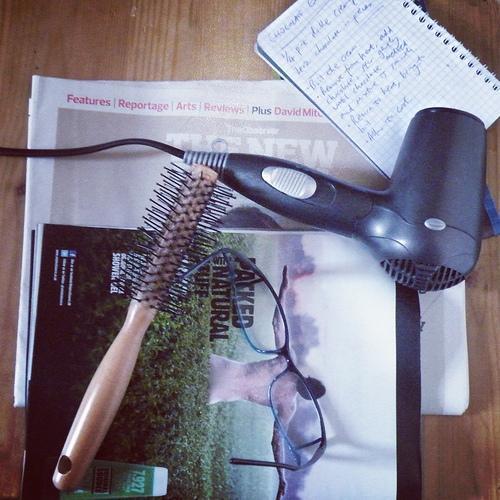How many brushes are there?
Give a very brief answer. 1. 